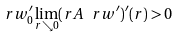<formula> <loc_0><loc_0><loc_500><loc_500>\ r w ^ { \prime } _ { 0 } \lim _ { r \searrow 0 } ( r A \ r w ^ { \prime } ) ^ { \prime } ( r ) > 0</formula> 